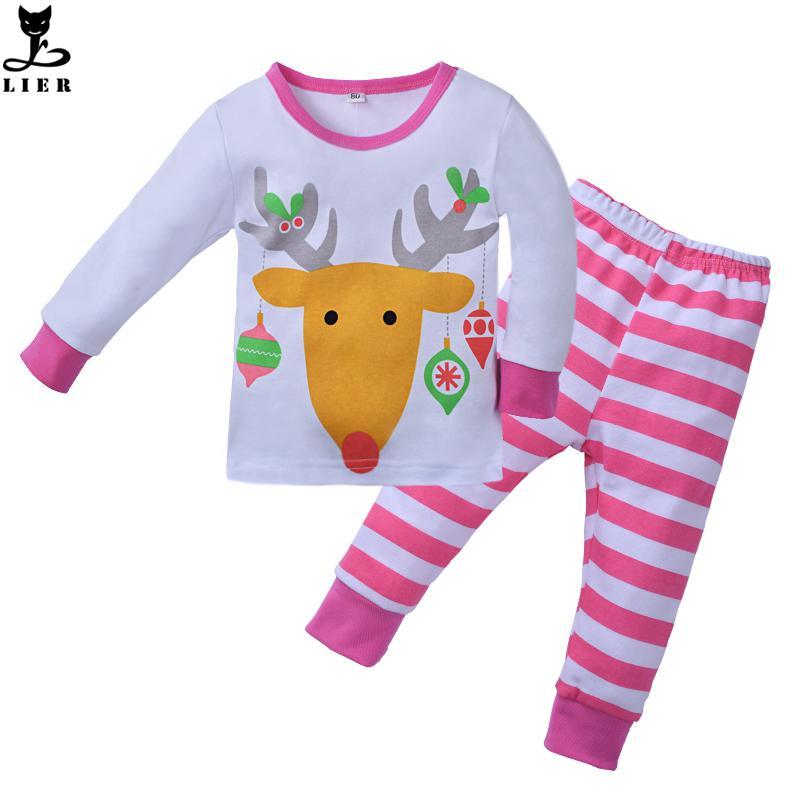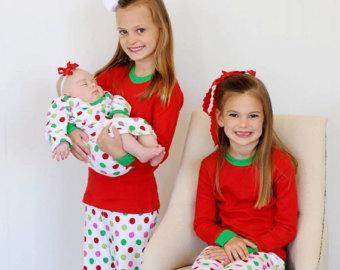The first image is the image on the left, the second image is the image on the right. For the images displayed, is the sentence "there are two pair of pajamas per image pair" factually correct? Answer yes or no. No. The first image is the image on the left, the second image is the image on the right. Considering the images on both sides, is "In one image there is a pair of pink Christmas children's pajamas in the center of the image." valid? Answer yes or no. Yes. 